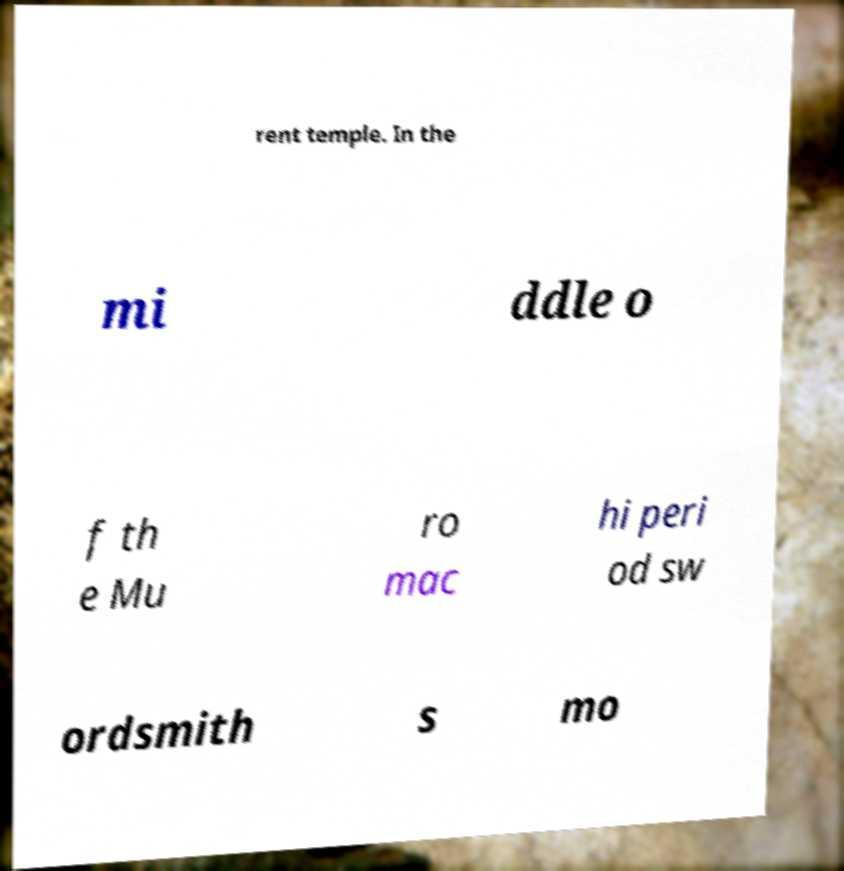Can you read and provide the text displayed in the image?This photo seems to have some interesting text. Can you extract and type it out for me? rent temple. In the mi ddle o f th e Mu ro mac hi peri od sw ordsmith s mo 